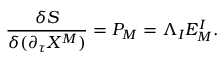<formula> <loc_0><loc_0><loc_500><loc_500>{ \frac { \delta S } { \delta ( \partial _ { \tau } X ^ { M } ) } } = P _ { M } = \Lambda _ { I } E _ { M } ^ { I } .</formula> 